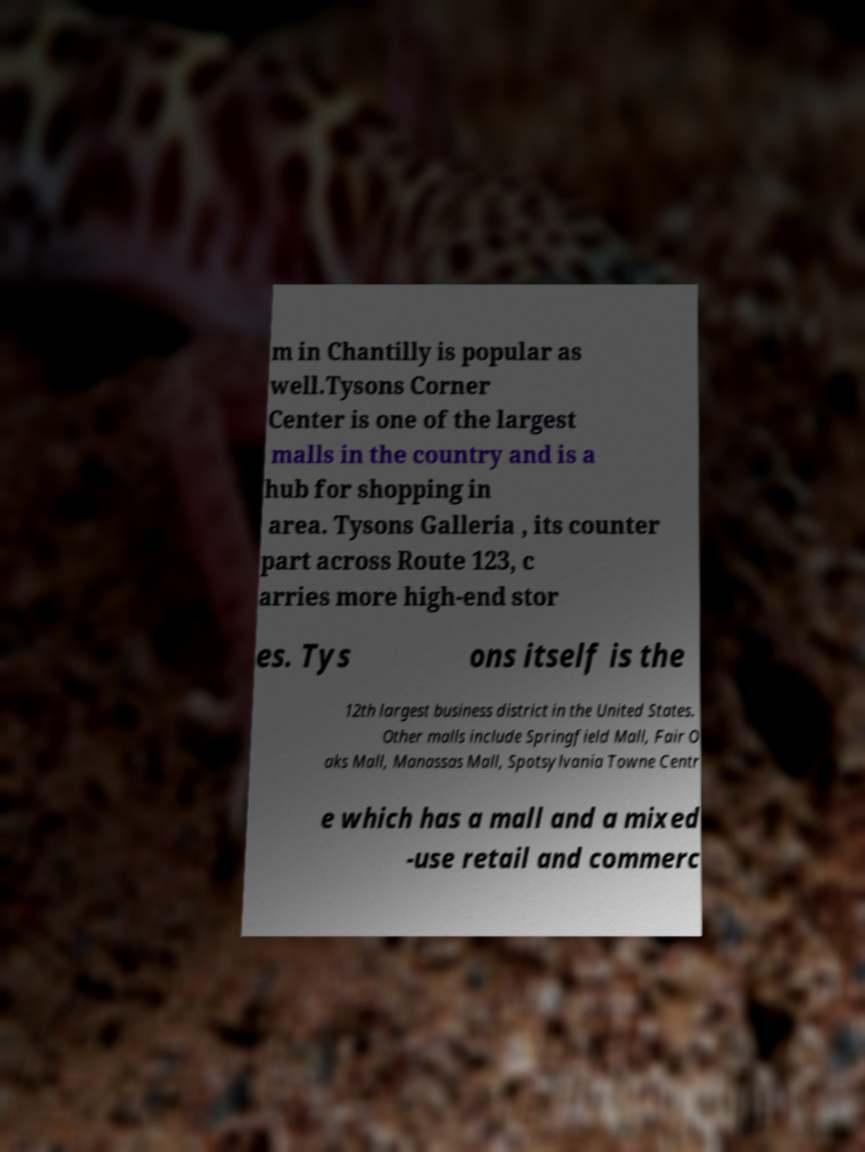Please read and relay the text visible in this image. What does it say? m in Chantilly is popular as well.Tysons Corner Center is one of the largest malls in the country and is a hub for shopping in area. Tysons Galleria , its counter part across Route 123, c arries more high-end stor es. Tys ons itself is the 12th largest business district in the United States. Other malls include Springfield Mall, Fair O aks Mall, Manassas Mall, Spotsylvania Towne Centr e which has a mall and a mixed -use retail and commerc 